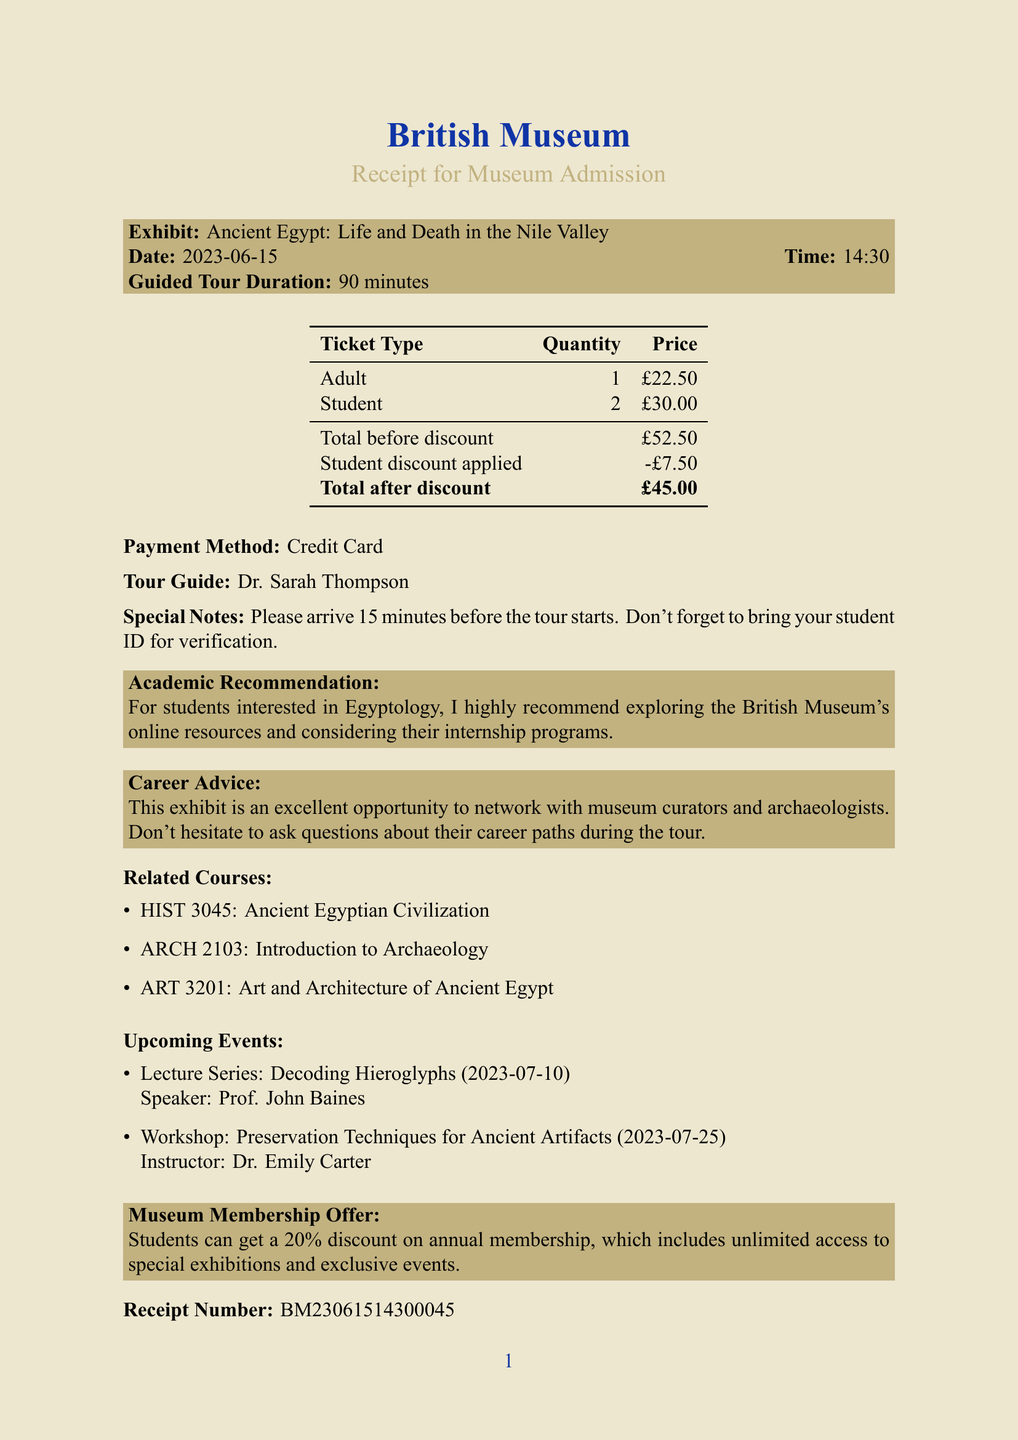What is the name of the museum? The name of the museum is clearly stated at the top of the receipt.
Answer: British Museum What is the date of the exhibit? The date of the exhibit is mentioned in the receipt under the exhibit details.
Answer: 2023-06-15 How long is the guided tour? The duration of the guided tour is specified in the document.
Answer: 90 minutes What is the total before discount? The total before any discounts are applied is listed in the pricing table.
Answer: £52.50 Who is the tour guide? The name of the tour guide is provided in the special notes section.
Answer: Dr. Sarah Thompson How much is the student discount? The amount of student discount applied is specified in the pricing details.
Answer: £7.50 What payment method was used? The payment method is mentioned in the receipt under payment details.
Answer: Credit Card What is the receipt number? The receipt number is found at the bottom of the document.
Answer: BM23061514300045 What is the recommended course for aspiring Egyptologists? The related courses are listed, and one of them specifically targets Egyptology.
Answer: HIST 3045: Ancient Egyptian Civilization What is the upcoming workshop about? The upcoming events section describes various upcoming activities, including the workshop topic.
Answer: Preservation Techniques for Ancient Artifacts 